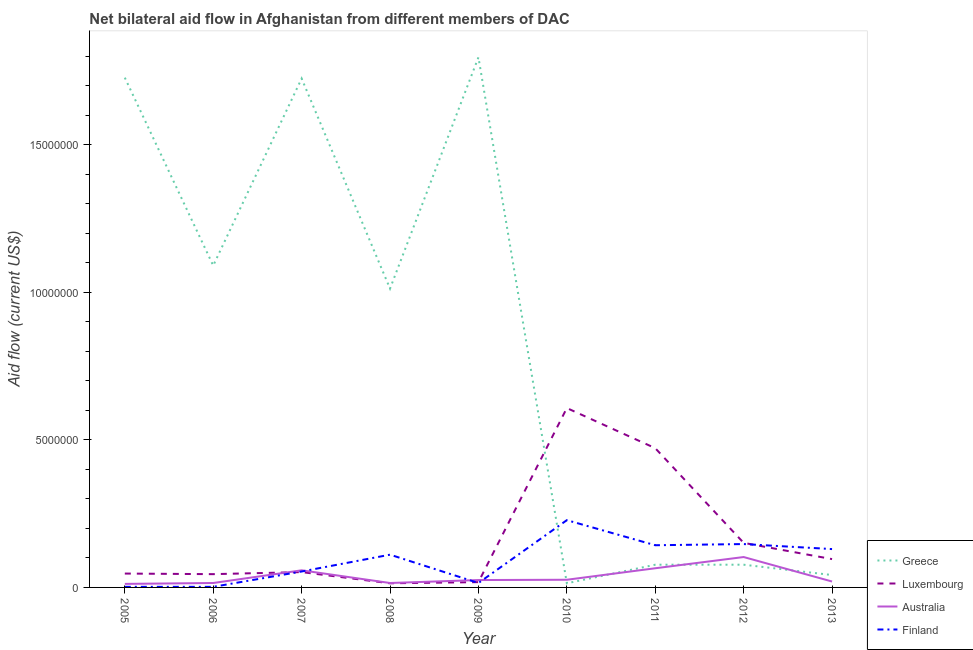How many different coloured lines are there?
Your answer should be very brief. 4. Does the line corresponding to amount of aid given by greece intersect with the line corresponding to amount of aid given by australia?
Give a very brief answer. Yes. What is the amount of aid given by finland in 2011?
Offer a terse response. 1.43e+06. Across all years, what is the maximum amount of aid given by greece?
Your response must be concise. 1.80e+07. Across all years, what is the minimum amount of aid given by finland?
Offer a terse response. 2.00e+04. In which year was the amount of aid given by luxembourg maximum?
Make the answer very short. 2010. In which year was the amount of aid given by australia minimum?
Offer a very short reply. 2005. What is the total amount of aid given by greece in the graph?
Your answer should be very brief. 7.56e+07. What is the difference between the amount of aid given by australia in 2008 and that in 2009?
Provide a succinct answer. -1.00e+05. What is the difference between the amount of aid given by greece in 2012 and the amount of aid given by australia in 2010?
Ensure brevity in your answer.  5.10e+05. What is the average amount of aid given by finland per year?
Keep it short and to the point. 9.24e+05. In the year 2007, what is the difference between the amount of aid given by greece and amount of aid given by australia?
Offer a very short reply. 1.67e+07. What is the ratio of the amount of aid given by finland in 2006 to that in 2007?
Provide a short and direct response. 0.04. Is the difference between the amount of aid given by australia in 2005 and 2007 greater than the difference between the amount of aid given by finland in 2005 and 2007?
Provide a succinct answer. Yes. What is the difference between the highest and the second highest amount of aid given by greece?
Your answer should be compact. 6.90e+05. What is the difference between the highest and the lowest amount of aid given by luxembourg?
Make the answer very short. 5.94e+06. In how many years, is the amount of aid given by australia greater than the average amount of aid given by australia taken over all years?
Provide a succinct answer. 3. Is the sum of the amount of aid given by australia in 2007 and 2010 greater than the maximum amount of aid given by finland across all years?
Offer a terse response. No. Is the amount of aid given by luxembourg strictly greater than the amount of aid given by australia over the years?
Ensure brevity in your answer.  No. How many lines are there?
Provide a short and direct response. 4. How many years are there in the graph?
Make the answer very short. 9. Are the values on the major ticks of Y-axis written in scientific E-notation?
Make the answer very short. No. Does the graph contain any zero values?
Offer a terse response. No. Does the graph contain grids?
Offer a very short reply. No. Where does the legend appear in the graph?
Give a very brief answer. Bottom right. What is the title of the graph?
Keep it short and to the point. Net bilateral aid flow in Afghanistan from different members of DAC. What is the Aid flow (current US$) in Greece in 2005?
Give a very brief answer. 1.73e+07. What is the Aid flow (current US$) in Australia in 2005?
Offer a terse response. 1.20e+05. What is the Aid flow (current US$) of Finland in 2005?
Your answer should be very brief. 2.00e+04. What is the Aid flow (current US$) of Greece in 2006?
Ensure brevity in your answer.  1.09e+07. What is the Aid flow (current US$) of Australia in 2006?
Give a very brief answer. 1.50e+05. What is the Aid flow (current US$) in Greece in 2007?
Keep it short and to the point. 1.72e+07. What is the Aid flow (current US$) of Luxembourg in 2007?
Give a very brief answer. 5.20e+05. What is the Aid flow (current US$) of Australia in 2007?
Make the answer very short. 5.80e+05. What is the Aid flow (current US$) of Finland in 2007?
Ensure brevity in your answer.  5.40e+05. What is the Aid flow (current US$) of Greece in 2008?
Provide a succinct answer. 1.01e+07. What is the Aid flow (current US$) in Finland in 2008?
Your answer should be very brief. 1.11e+06. What is the Aid flow (current US$) of Greece in 2009?
Provide a short and direct response. 1.80e+07. What is the Aid flow (current US$) in Australia in 2009?
Give a very brief answer. 2.50e+05. What is the Aid flow (current US$) of Greece in 2010?
Provide a short and direct response. 1.40e+05. What is the Aid flow (current US$) in Luxembourg in 2010?
Give a very brief answer. 6.08e+06. What is the Aid flow (current US$) in Finland in 2010?
Provide a succinct answer. 2.28e+06. What is the Aid flow (current US$) of Greece in 2011?
Make the answer very short. 7.70e+05. What is the Aid flow (current US$) in Luxembourg in 2011?
Ensure brevity in your answer.  4.72e+06. What is the Aid flow (current US$) in Australia in 2011?
Your answer should be compact. 6.50e+05. What is the Aid flow (current US$) in Finland in 2011?
Offer a terse response. 1.43e+06. What is the Aid flow (current US$) in Greece in 2012?
Your answer should be very brief. 7.70e+05. What is the Aid flow (current US$) in Luxembourg in 2012?
Give a very brief answer. 1.51e+06. What is the Aid flow (current US$) of Australia in 2012?
Your answer should be compact. 1.03e+06. What is the Aid flow (current US$) in Finland in 2012?
Keep it short and to the point. 1.47e+06. What is the Aid flow (current US$) in Greece in 2013?
Ensure brevity in your answer.  4.20e+05. What is the Aid flow (current US$) of Luxembourg in 2013?
Ensure brevity in your answer.  9.60e+05. What is the Aid flow (current US$) in Australia in 2013?
Ensure brevity in your answer.  2.00e+05. What is the Aid flow (current US$) in Finland in 2013?
Give a very brief answer. 1.30e+06. Across all years, what is the maximum Aid flow (current US$) of Greece?
Provide a succinct answer. 1.80e+07. Across all years, what is the maximum Aid flow (current US$) of Luxembourg?
Your answer should be compact. 6.08e+06. Across all years, what is the maximum Aid flow (current US$) of Australia?
Keep it short and to the point. 1.03e+06. Across all years, what is the maximum Aid flow (current US$) in Finland?
Your response must be concise. 2.28e+06. Across all years, what is the minimum Aid flow (current US$) of Greece?
Offer a terse response. 1.40e+05. Across all years, what is the minimum Aid flow (current US$) in Luxembourg?
Give a very brief answer. 1.40e+05. Across all years, what is the minimum Aid flow (current US$) in Australia?
Your response must be concise. 1.20e+05. Across all years, what is the minimum Aid flow (current US$) of Finland?
Ensure brevity in your answer.  2.00e+04. What is the total Aid flow (current US$) of Greece in the graph?
Your answer should be very brief. 7.56e+07. What is the total Aid flow (current US$) in Luxembourg in the graph?
Your answer should be very brief. 1.50e+07. What is the total Aid flow (current US$) in Australia in the graph?
Ensure brevity in your answer.  3.39e+06. What is the total Aid flow (current US$) of Finland in the graph?
Your response must be concise. 8.32e+06. What is the difference between the Aid flow (current US$) of Greece in 2005 and that in 2006?
Provide a short and direct response. 6.37e+06. What is the difference between the Aid flow (current US$) in Luxembourg in 2005 and that in 2006?
Give a very brief answer. 2.00e+04. What is the difference between the Aid flow (current US$) in Australia in 2005 and that in 2006?
Make the answer very short. -3.00e+04. What is the difference between the Aid flow (current US$) of Finland in 2005 and that in 2006?
Your response must be concise. 0. What is the difference between the Aid flow (current US$) of Greece in 2005 and that in 2007?
Offer a very short reply. 3.00e+04. What is the difference between the Aid flow (current US$) in Luxembourg in 2005 and that in 2007?
Offer a very short reply. -5.00e+04. What is the difference between the Aid flow (current US$) in Australia in 2005 and that in 2007?
Your answer should be compact. -4.60e+05. What is the difference between the Aid flow (current US$) of Finland in 2005 and that in 2007?
Offer a terse response. -5.20e+05. What is the difference between the Aid flow (current US$) in Greece in 2005 and that in 2008?
Ensure brevity in your answer.  7.15e+06. What is the difference between the Aid flow (current US$) of Finland in 2005 and that in 2008?
Your response must be concise. -1.09e+06. What is the difference between the Aid flow (current US$) of Greece in 2005 and that in 2009?
Provide a succinct answer. -6.90e+05. What is the difference between the Aid flow (current US$) of Luxembourg in 2005 and that in 2009?
Keep it short and to the point. 2.90e+05. What is the difference between the Aid flow (current US$) of Australia in 2005 and that in 2009?
Your answer should be compact. -1.30e+05. What is the difference between the Aid flow (current US$) in Finland in 2005 and that in 2009?
Ensure brevity in your answer.  -1.30e+05. What is the difference between the Aid flow (current US$) of Greece in 2005 and that in 2010?
Provide a succinct answer. 1.71e+07. What is the difference between the Aid flow (current US$) in Luxembourg in 2005 and that in 2010?
Ensure brevity in your answer.  -5.61e+06. What is the difference between the Aid flow (current US$) in Finland in 2005 and that in 2010?
Ensure brevity in your answer.  -2.26e+06. What is the difference between the Aid flow (current US$) of Greece in 2005 and that in 2011?
Give a very brief answer. 1.65e+07. What is the difference between the Aid flow (current US$) in Luxembourg in 2005 and that in 2011?
Your response must be concise. -4.25e+06. What is the difference between the Aid flow (current US$) of Australia in 2005 and that in 2011?
Offer a terse response. -5.30e+05. What is the difference between the Aid flow (current US$) of Finland in 2005 and that in 2011?
Give a very brief answer. -1.41e+06. What is the difference between the Aid flow (current US$) of Greece in 2005 and that in 2012?
Your response must be concise. 1.65e+07. What is the difference between the Aid flow (current US$) in Luxembourg in 2005 and that in 2012?
Give a very brief answer. -1.04e+06. What is the difference between the Aid flow (current US$) of Australia in 2005 and that in 2012?
Offer a terse response. -9.10e+05. What is the difference between the Aid flow (current US$) of Finland in 2005 and that in 2012?
Your answer should be compact. -1.45e+06. What is the difference between the Aid flow (current US$) of Greece in 2005 and that in 2013?
Your answer should be compact. 1.69e+07. What is the difference between the Aid flow (current US$) in Luxembourg in 2005 and that in 2013?
Keep it short and to the point. -4.90e+05. What is the difference between the Aid flow (current US$) in Finland in 2005 and that in 2013?
Offer a very short reply. -1.28e+06. What is the difference between the Aid flow (current US$) in Greece in 2006 and that in 2007?
Offer a terse response. -6.34e+06. What is the difference between the Aid flow (current US$) in Australia in 2006 and that in 2007?
Your answer should be compact. -4.30e+05. What is the difference between the Aid flow (current US$) of Finland in 2006 and that in 2007?
Provide a succinct answer. -5.20e+05. What is the difference between the Aid flow (current US$) in Greece in 2006 and that in 2008?
Provide a succinct answer. 7.80e+05. What is the difference between the Aid flow (current US$) in Australia in 2006 and that in 2008?
Provide a succinct answer. 0. What is the difference between the Aid flow (current US$) in Finland in 2006 and that in 2008?
Provide a succinct answer. -1.09e+06. What is the difference between the Aid flow (current US$) in Greece in 2006 and that in 2009?
Offer a very short reply. -7.06e+06. What is the difference between the Aid flow (current US$) in Luxembourg in 2006 and that in 2009?
Provide a succinct answer. 2.70e+05. What is the difference between the Aid flow (current US$) in Greece in 2006 and that in 2010?
Your answer should be compact. 1.08e+07. What is the difference between the Aid flow (current US$) of Luxembourg in 2006 and that in 2010?
Provide a succinct answer. -5.63e+06. What is the difference between the Aid flow (current US$) of Australia in 2006 and that in 2010?
Your response must be concise. -1.10e+05. What is the difference between the Aid flow (current US$) of Finland in 2006 and that in 2010?
Keep it short and to the point. -2.26e+06. What is the difference between the Aid flow (current US$) of Greece in 2006 and that in 2011?
Provide a short and direct response. 1.01e+07. What is the difference between the Aid flow (current US$) of Luxembourg in 2006 and that in 2011?
Your answer should be very brief. -4.27e+06. What is the difference between the Aid flow (current US$) in Australia in 2006 and that in 2011?
Your answer should be compact. -5.00e+05. What is the difference between the Aid flow (current US$) of Finland in 2006 and that in 2011?
Your response must be concise. -1.41e+06. What is the difference between the Aid flow (current US$) of Greece in 2006 and that in 2012?
Your answer should be very brief. 1.01e+07. What is the difference between the Aid flow (current US$) in Luxembourg in 2006 and that in 2012?
Your answer should be compact. -1.06e+06. What is the difference between the Aid flow (current US$) in Australia in 2006 and that in 2012?
Offer a very short reply. -8.80e+05. What is the difference between the Aid flow (current US$) in Finland in 2006 and that in 2012?
Your answer should be compact. -1.45e+06. What is the difference between the Aid flow (current US$) in Greece in 2006 and that in 2013?
Make the answer very short. 1.05e+07. What is the difference between the Aid flow (current US$) of Luxembourg in 2006 and that in 2013?
Provide a succinct answer. -5.10e+05. What is the difference between the Aid flow (current US$) of Finland in 2006 and that in 2013?
Provide a succinct answer. -1.28e+06. What is the difference between the Aid flow (current US$) in Greece in 2007 and that in 2008?
Your answer should be very brief. 7.12e+06. What is the difference between the Aid flow (current US$) of Luxembourg in 2007 and that in 2008?
Offer a very short reply. 3.80e+05. What is the difference between the Aid flow (current US$) in Australia in 2007 and that in 2008?
Your answer should be very brief. 4.30e+05. What is the difference between the Aid flow (current US$) in Finland in 2007 and that in 2008?
Your answer should be very brief. -5.70e+05. What is the difference between the Aid flow (current US$) in Greece in 2007 and that in 2009?
Keep it short and to the point. -7.20e+05. What is the difference between the Aid flow (current US$) of Luxembourg in 2007 and that in 2009?
Provide a short and direct response. 3.40e+05. What is the difference between the Aid flow (current US$) in Greece in 2007 and that in 2010?
Your response must be concise. 1.71e+07. What is the difference between the Aid flow (current US$) in Luxembourg in 2007 and that in 2010?
Offer a very short reply. -5.56e+06. What is the difference between the Aid flow (current US$) of Australia in 2007 and that in 2010?
Ensure brevity in your answer.  3.20e+05. What is the difference between the Aid flow (current US$) of Finland in 2007 and that in 2010?
Ensure brevity in your answer.  -1.74e+06. What is the difference between the Aid flow (current US$) in Greece in 2007 and that in 2011?
Offer a terse response. 1.65e+07. What is the difference between the Aid flow (current US$) of Luxembourg in 2007 and that in 2011?
Make the answer very short. -4.20e+06. What is the difference between the Aid flow (current US$) in Finland in 2007 and that in 2011?
Ensure brevity in your answer.  -8.90e+05. What is the difference between the Aid flow (current US$) in Greece in 2007 and that in 2012?
Offer a very short reply. 1.65e+07. What is the difference between the Aid flow (current US$) in Luxembourg in 2007 and that in 2012?
Keep it short and to the point. -9.90e+05. What is the difference between the Aid flow (current US$) of Australia in 2007 and that in 2012?
Keep it short and to the point. -4.50e+05. What is the difference between the Aid flow (current US$) of Finland in 2007 and that in 2012?
Offer a terse response. -9.30e+05. What is the difference between the Aid flow (current US$) of Greece in 2007 and that in 2013?
Offer a terse response. 1.68e+07. What is the difference between the Aid flow (current US$) of Luxembourg in 2007 and that in 2013?
Your response must be concise. -4.40e+05. What is the difference between the Aid flow (current US$) in Australia in 2007 and that in 2013?
Provide a succinct answer. 3.80e+05. What is the difference between the Aid flow (current US$) in Finland in 2007 and that in 2013?
Keep it short and to the point. -7.60e+05. What is the difference between the Aid flow (current US$) of Greece in 2008 and that in 2009?
Offer a terse response. -7.84e+06. What is the difference between the Aid flow (current US$) in Finland in 2008 and that in 2009?
Your response must be concise. 9.60e+05. What is the difference between the Aid flow (current US$) in Greece in 2008 and that in 2010?
Ensure brevity in your answer.  9.99e+06. What is the difference between the Aid flow (current US$) of Luxembourg in 2008 and that in 2010?
Ensure brevity in your answer.  -5.94e+06. What is the difference between the Aid flow (current US$) of Australia in 2008 and that in 2010?
Ensure brevity in your answer.  -1.10e+05. What is the difference between the Aid flow (current US$) of Finland in 2008 and that in 2010?
Ensure brevity in your answer.  -1.17e+06. What is the difference between the Aid flow (current US$) of Greece in 2008 and that in 2011?
Ensure brevity in your answer.  9.36e+06. What is the difference between the Aid flow (current US$) of Luxembourg in 2008 and that in 2011?
Provide a succinct answer. -4.58e+06. What is the difference between the Aid flow (current US$) in Australia in 2008 and that in 2011?
Provide a succinct answer. -5.00e+05. What is the difference between the Aid flow (current US$) of Finland in 2008 and that in 2011?
Provide a short and direct response. -3.20e+05. What is the difference between the Aid flow (current US$) in Greece in 2008 and that in 2012?
Offer a very short reply. 9.36e+06. What is the difference between the Aid flow (current US$) in Luxembourg in 2008 and that in 2012?
Provide a succinct answer. -1.37e+06. What is the difference between the Aid flow (current US$) of Australia in 2008 and that in 2012?
Offer a terse response. -8.80e+05. What is the difference between the Aid flow (current US$) of Finland in 2008 and that in 2012?
Provide a succinct answer. -3.60e+05. What is the difference between the Aid flow (current US$) in Greece in 2008 and that in 2013?
Provide a short and direct response. 9.71e+06. What is the difference between the Aid flow (current US$) of Luxembourg in 2008 and that in 2013?
Your answer should be very brief. -8.20e+05. What is the difference between the Aid flow (current US$) in Finland in 2008 and that in 2013?
Keep it short and to the point. -1.90e+05. What is the difference between the Aid flow (current US$) in Greece in 2009 and that in 2010?
Your response must be concise. 1.78e+07. What is the difference between the Aid flow (current US$) in Luxembourg in 2009 and that in 2010?
Provide a short and direct response. -5.90e+06. What is the difference between the Aid flow (current US$) of Australia in 2009 and that in 2010?
Your answer should be very brief. -10000. What is the difference between the Aid flow (current US$) in Finland in 2009 and that in 2010?
Ensure brevity in your answer.  -2.13e+06. What is the difference between the Aid flow (current US$) in Greece in 2009 and that in 2011?
Ensure brevity in your answer.  1.72e+07. What is the difference between the Aid flow (current US$) in Luxembourg in 2009 and that in 2011?
Your answer should be compact. -4.54e+06. What is the difference between the Aid flow (current US$) in Australia in 2009 and that in 2011?
Give a very brief answer. -4.00e+05. What is the difference between the Aid flow (current US$) in Finland in 2009 and that in 2011?
Your response must be concise. -1.28e+06. What is the difference between the Aid flow (current US$) in Greece in 2009 and that in 2012?
Provide a short and direct response. 1.72e+07. What is the difference between the Aid flow (current US$) in Luxembourg in 2009 and that in 2012?
Offer a terse response. -1.33e+06. What is the difference between the Aid flow (current US$) of Australia in 2009 and that in 2012?
Provide a succinct answer. -7.80e+05. What is the difference between the Aid flow (current US$) of Finland in 2009 and that in 2012?
Your answer should be very brief. -1.32e+06. What is the difference between the Aid flow (current US$) of Greece in 2009 and that in 2013?
Provide a succinct answer. 1.76e+07. What is the difference between the Aid flow (current US$) of Luxembourg in 2009 and that in 2013?
Provide a short and direct response. -7.80e+05. What is the difference between the Aid flow (current US$) of Australia in 2009 and that in 2013?
Your answer should be very brief. 5.00e+04. What is the difference between the Aid flow (current US$) in Finland in 2009 and that in 2013?
Offer a very short reply. -1.15e+06. What is the difference between the Aid flow (current US$) in Greece in 2010 and that in 2011?
Provide a succinct answer. -6.30e+05. What is the difference between the Aid flow (current US$) in Luxembourg in 2010 and that in 2011?
Provide a succinct answer. 1.36e+06. What is the difference between the Aid flow (current US$) in Australia in 2010 and that in 2011?
Provide a succinct answer. -3.90e+05. What is the difference between the Aid flow (current US$) of Finland in 2010 and that in 2011?
Ensure brevity in your answer.  8.50e+05. What is the difference between the Aid flow (current US$) of Greece in 2010 and that in 2012?
Make the answer very short. -6.30e+05. What is the difference between the Aid flow (current US$) in Luxembourg in 2010 and that in 2012?
Provide a succinct answer. 4.57e+06. What is the difference between the Aid flow (current US$) of Australia in 2010 and that in 2012?
Provide a short and direct response. -7.70e+05. What is the difference between the Aid flow (current US$) in Finland in 2010 and that in 2012?
Make the answer very short. 8.10e+05. What is the difference between the Aid flow (current US$) of Greece in 2010 and that in 2013?
Provide a succinct answer. -2.80e+05. What is the difference between the Aid flow (current US$) in Luxembourg in 2010 and that in 2013?
Your answer should be very brief. 5.12e+06. What is the difference between the Aid flow (current US$) of Australia in 2010 and that in 2013?
Your answer should be compact. 6.00e+04. What is the difference between the Aid flow (current US$) in Finland in 2010 and that in 2013?
Provide a succinct answer. 9.80e+05. What is the difference between the Aid flow (current US$) of Luxembourg in 2011 and that in 2012?
Give a very brief answer. 3.21e+06. What is the difference between the Aid flow (current US$) in Australia in 2011 and that in 2012?
Your answer should be compact. -3.80e+05. What is the difference between the Aid flow (current US$) in Greece in 2011 and that in 2013?
Provide a succinct answer. 3.50e+05. What is the difference between the Aid flow (current US$) in Luxembourg in 2011 and that in 2013?
Offer a very short reply. 3.76e+06. What is the difference between the Aid flow (current US$) of Greece in 2012 and that in 2013?
Provide a succinct answer. 3.50e+05. What is the difference between the Aid flow (current US$) of Australia in 2012 and that in 2013?
Offer a very short reply. 8.30e+05. What is the difference between the Aid flow (current US$) of Greece in 2005 and the Aid flow (current US$) of Luxembourg in 2006?
Your answer should be compact. 1.68e+07. What is the difference between the Aid flow (current US$) in Greece in 2005 and the Aid flow (current US$) in Australia in 2006?
Offer a very short reply. 1.71e+07. What is the difference between the Aid flow (current US$) of Greece in 2005 and the Aid flow (current US$) of Finland in 2006?
Your response must be concise. 1.73e+07. What is the difference between the Aid flow (current US$) in Australia in 2005 and the Aid flow (current US$) in Finland in 2006?
Make the answer very short. 1.00e+05. What is the difference between the Aid flow (current US$) in Greece in 2005 and the Aid flow (current US$) in Luxembourg in 2007?
Offer a very short reply. 1.68e+07. What is the difference between the Aid flow (current US$) of Greece in 2005 and the Aid flow (current US$) of Australia in 2007?
Make the answer very short. 1.67e+07. What is the difference between the Aid flow (current US$) in Greece in 2005 and the Aid flow (current US$) in Finland in 2007?
Offer a very short reply. 1.67e+07. What is the difference between the Aid flow (current US$) in Luxembourg in 2005 and the Aid flow (current US$) in Australia in 2007?
Provide a succinct answer. -1.10e+05. What is the difference between the Aid flow (current US$) in Luxembourg in 2005 and the Aid flow (current US$) in Finland in 2007?
Ensure brevity in your answer.  -7.00e+04. What is the difference between the Aid flow (current US$) of Australia in 2005 and the Aid flow (current US$) of Finland in 2007?
Your answer should be very brief. -4.20e+05. What is the difference between the Aid flow (current US$) in Greece in 2005 and the Aid flow (current US$) in Luxembourg in 2008?
Provide a succinct answer. 1.71e+07. What is the difference between the Aid flow (current US$) in Greece in 2005 and the Aid flow (current US$) in Australia in 2008?
Your answer should be compact. 1.71e+07. What is the difference between the Aid flow (current US$) in Greece in 2005 and the Aid flow (current US$) in Finland in 2008?
Your response must be concise. 1.62e+07. What is the difference between the Aid flow (current US$) of Luxembourg in 2005 and the Aid flow (current US$) of Australia in 2008?
Your response must be concise. 3.20e+05. What is the difference between the Aid flow (current US$) in Luxembourg in 2005 and the Aid flow (current US$) in Finland in 2008?
Make the answer very short. -6.40e+05. What is the difference between the Aid flow (current US$) of Australia in 2005 and the Aid flow (current US$) of Finland in 2008?
Your answer should be very brief. -9.90e+05. What is the difference between the Aid flow (current US$) in Greece in 2005 and the Aid flow (current US$) in Luxembourg in 2009?
Your response must be concise. 1.71e+07. What is the difference between the Aid flow (current US$) in Greece in 2005 and the Aid flow (current US$) in Australia in 2009?
Ensure brevity in your answer.  1.70e+07. What is the difference between the Aid flow (current US$) in Greece in 2005 and the Aid flow (current US$) in Finland in 2009?
Your answer should be compact. 1.71e+07. What is the difference between the Aid flow (current US$) of Luxembourg in 2005 and the Aid flow (current US$) of Finland in 2009?
Ensure brevity in your answer.  3.20e+05. What is the difference between the Aid flow (current US$) in Australia in 2005 and the Aid flow (current US$) in Finland in 2009?
Provide a succinct answer. -3.00e+04. What is the difference between the Aid flow (current US$) in Greece in 2005 and the Aid flow (current US$) in Luxembourg in 2010?
Offer a terse response. 1.12e+07. What is the difference between the Aid flow (current US$) of Greece in 2005 and the Aid flow (current US$) of Australia in 2010?
Make the answer very short. 1.70e+07. What is the difference between the Aid flow (current US$) in Greece in 2005 and the Aid flow (current US$) in Finland in 2010?
Ensure brevity in your answer.  1.50e+07. What is the difference between the Aid flow (current US$) in Luxembourg in 2005 and the Aid flow (current US$) in Australia in 2010?
Ensure brevity in your answer.  2.10e+05. What is the difference between the Aid flow (current US$) of Luxembourg in 2005 and the Aid flow (current US$) of Finland in 2010?
Ensure brevity in your answer.  -1.81e+06. What is the difference between the Aid flow (current US$) of Australia in 2005 and the Aid flow (current US$) of Finland in 2010?
Provide a succinct answer. -2.16e+06. What is the difference between the Aid flow (current US$) in Greece in 2005 and the Aid flow (current US$) in Luxembourg in 2011?
Offer a terse response. 1.26e+07. What is the difference between the Aid flow (current US$) in Greece in 2005 and the Aid flow (current US$) in Australia in 2011?
Provide a succinct answer. 1.66e+07. What is the difference between the Aid flow (current US$) in Greece in 2005 and the Aid flow (current US$) in Finland in 2011?
Keep it short and to the point. 1.58e+07. What is the difference between the Aid flow (current US$) of Luxembourg in 2005 and the Aid flow (current US$) of Australia in 2011?
Your answer should be compact. -1.80e+05. What is the difference between the Aid flow (current US$) of Luxembourg in 2005 and the Aid flow (current US$) of Finland in 2011?
Give a very brief answer. -9.60e+05. What is the difference between the Aid flow (current US$) in Australia in 2005 and the Aid flow (current US$) in Finland in 2011?
Provide a succinct answer. -1.31e+06. What is the difference between the Aid flow (current US$) in Greece in 2005 and the Aid flow (current US$) in Luxembourg in 2012?
Give a very brief answer. 1.58e+07. What is the difference between the Aid flow (current US$) in Greece in 2005 and the Aid flow (current US$) in Australia in 2012?
Your answer should be compact. 1.62e+07. What is the difference between the Aid flow (current US$) of Greece in 2005 and the Aid flow (current US$) of Finland in 2012?
Offer a very short reply. 1.58e+07. What is the difference between the Aid flow (current US$) of Luxembourg in 2005 and the Aid flow (current US$) of Australia in 2012?
Your answer should be very brief. -5.60e+05. What is the difference between the Aid flow (current US$) of Luxembourg in 2005 and the Aid flow (current US$) of Finland in 2012?
Your answer should be very brief. -1.00e+06. What is the difference between the Aid flow (current US$) in Australia in 2005 and the Aid flow (current US$) in Finland in 2012?
Your answer should be very brief. -1.35e+06. What is the difference between the Aid flow (current US$) in Greece in 2005 and the Aid flow (current US$) in Luxembourg in 2013?
Provide a succinct answer. 1.63e+07. What is the difference between the Aid flow (current US$) in Greece in 2005 and the Aid flow (current US$) in Australia in 2013?
Offer a terse response. 1.71e+07. What is the difference between the Aid flow (current US$) of Greece in 2005 and the Aid flow (current US$) of Finland in 2013?
Offer a very short reply. 1.60e+07. What is the difference between the Aid flow (current US$) in Luxembourg in 2005 and the Aid flow (current US$) in Australia in 2013?
Give a very brief answer. 2.70e+05. What is the difference between the Aid flow (current US$) of Luxembourg in 2005 and the Aid flow (current US$) of Finland in 2013?
Give a very brief answer. -8.30e+05. What is the difference between the Aid flow (current US$) in Australia in 2005 and the Aid flow (current US$) in Finland in 2013?
Keep it short and to the point. -1.18e+06. What is the difference between the Aid flow (current US$) in Greece in 2006 and the Aid flow (current US$) in Luxembourg in 2007?
Your answer should be compact. 1.04e+07. What is the difference between the Aid flow (current US$) of Greece in 2006 and the Aid flow (current US$) of Australia in 2007?
Your answer should be compact. 1.03e+07. What is the difference between the Aid flow (current US$) in Greece in 2006 and the Aid flow (current US$) in Finland in 2007?
Keep it short and to the point. 1.04e+07. What is the difference between the Aid flow (current US$) of Luxembourg in 2006 and the Aid flow (current US$) of Australia in 2007?
Offer a very short reply. -1.30e+05. What is the difference between the Aid flow (current US$) of Australia in 2006 and the Aid flow (current US$) of Finland in 2007?
Provide a short and direct response. -3.90e+05. What is the difference between the Aid flow (current US$) in Greece in 2006 and the Aid flow (current US$) in Luxembourg in 2008?
Your answer should be very brief. 1.08e+07. What is the difference between the Aid flow (current US$) of Greece in 2006 and the Aid flow (current US$) of Australia in 2008?
Keep it short and to the point. 1.08e+07. What is the difference between the Aid flow (current US$) in Greece in 2006 and the Aid flow (current US$) in Finland in 2008?
Offer a very short reply. 9.80e+06. What is the difference between the Aid flow (current US$) in Luxembourg in 2006 and the Aid flow (current US$) in Finland in 2008?
Keep it short and to the point. -6.60e+05. What is the difference between the Aid flow (current US$) in Australia in 2006 and the Aid flow (current US$) in Finland in 2008?
Offer a terse response. -9.60e+05. What is the difference between the Aid flow (current US$) in Greece in 2006 and the Aid flow (current US$) in Luxembourg in 2009?
Ensure brevity in your answer.  1.07e+07. What is the difference between the Aid flow (current US$) in Greece in 2006 and the Aid flow (current US$) in Australia in 2009?
Your answer should be very brief. 1.07e+07. What is the difference between the Aid flow (current US$) of Greece in 2006 and the Aid flow (current US$) of Finland in 2009?
Your response must be concise. 1.08e+07. What is the difference between the Aid flow (current US$) in Luxembourg in 2006 and the Aid flow (current US$) in Finland in 2009?
Give a very brief answer. 3.00e+05. What is the difference between the Aid flow (current US$) in Australia in 2006 and the Aid flow (current US$) in Finland in 2009?
Your answer should be very brief. 0. What is the difference between the Aid flow (current US$) in Greece in 2006 and the Aid flow (current US$) in Luxembourg in 2010?
Provide a short and direct response. 4.83e+06. What is the difference between the Aid flow (current US$) in Greece in 2006 and the Aid flow (current US$) in Australia in 2010?
Provide a succinct answer. 1.06e+07. What is the difference between the Aid flow (current US$) of Greece in 2006 and the Aid flow (current US$) of Finland in 2010?
Make the answer very short. 8.63e+06. What is the difference between the Aid flow (current US$) in Luxembourg in 2006 and the Aid flow (current US$) in Australia in 2010?
Give a very brief answer. 1.90e+05. What is the difference between the Aid flow (current US$) of Luxembourg in 2006 and the Aid flow (current US$) of Finland in 2010?
Offer a terse response. -1.83e+06. What is the difference between the Aid flow (current US$) in Australia in 2006 and the Aid flow (current US$) in Finland in 2010?
Your answer should be very brief. -2.13e+06. What is the difference between the Aid flow (current US$) in Greece in 2006 and the Aid flow (current US$) in Luxembourg in 2011?
Provide a succinct answer. 6.19e+06. What is the difference between the Aid flow (current US$) of Greece in 2006 and the Aid flow (current US$) of Australia in 2011?
Provide a succinct answer. 1.03e+07. What is the difference between the Aid flow (current US$) of Greece in 2006 and the Aid flow (current US$) of Finland in 2011?
Ensure brevity in your answer.  9.48e+06. What is the difference between the Aid flow (current US$) in Luxembourg in 2006 and the Aid flow (current US$) in Australia in 2011?
Keep it short and to the point. -2.00e+05. What is the difference between the Aid flow (current US$) in Luxembourg in 2006 and the Aid flow (current US$) in Finland in 2011?
Give a very brief answer. -9.80e+05. What is the difference between the Aid flow (current US$) of Australia in 2006 and the Aid flow (current US$) of Finland in 2011?
Provide a short and direct response. -1.28e+06. What is the difference between the Aid flow (current US$) of Greece in 2006 and the Aid flow (current US$) of Luxembourg in 2012?
Make the answer very short. 9.40e+06. What is the difference between the Aid flow (current US$) of Greece in 2006 and the Aid flow (current US$) of Australia in 2012?
Your answer should be compact. 9.88e+06. What is the difference between the Aid flow (current US$) in Greece in 2006 and the Aid flow (current US$) in Finland in 2012?
Your answer should be compact. 9.44e+06. What is the difference between the Aid flow (current US$) of Luxembourg in 2006 and the Aid flow (current US$) of Australia in 2012?
Ensure brevity in your answer.  -5.80e+05. What is the difference between the Aid flow (current US$) in Luxembourg in 2006 and the Aid flow (current US$) in Finland in 2012?
Keep it short and to the point. -1.02e+06. What is the difference between the Aid flow (current US$) in Australia in 2006 and the Aid flow (current US$) in Finland in 2012?
Make the answer very short. -1.32e+06. What is the difference between the Aid flow (current US$) of Greece in 2006 and the Aid flow (current US$) of Luxembourg in 2013?
Make the answer very short. 9.95e+06. What is the difference between the Aid flow (current US$) in Greece in 2006 and the Aid flow (current US$) in Australia in 2013?
Your response must be concise. 1.07e+07. What is the difference between the Aid flow (current US$) in Greece in 2006 and the Aid flow (current US$) in Finland in 2013?
Your answer should be very brief. 9.61e+06. What is the difference between the Aid flow (current US$) in Luxembourg in 2006 and the Aid flow (current US$) in Finland in 2013?
Provide a short and direct response. -8.50e+05. What is the difference between the Aid flow (current US$) of Australia in 2006 and the Aid flow (current US$) of Finland in 2013?
Offer a terse response. -1.15e+06. What is the difference between the Aid flow (current US$) in Greece in 2007 and the Aid flow (current US$) in Luxembourg in 2008?
Keep it short and to the point. 1.71e+07. What is the difference between the Aid flow (current US$) of Greece in 2007 and the Aid flow (current US$) of Australia in 2008?
Your answer should be very brief. 1.71e+07. What is the difference between the Aid flow (current US$) in Greece in 2007 and the Aid flow (current US$) in Finland in 2008?
Keep it short and to the point. 1.61e+07. What is the difference between the Aid flow (current US$) in Luxembourg in 2007 and the Aid flow (current US$) in Australia in 2008?
Offer a terse response. 3.70e+05. What is the difference between the Aid flow (current US$) of Luxembourg in 2007 and the Aid flow (current US$) of Finland in 2008?
Make the answer very short. -5.90e+05. What is the difference between the Aid flow (current US$) in Australia in 2007 and the Aid flow (current US$) in Finland in 2008?
Your answer should be very brief. -5.30e+05. What is the difference between the Aid flow (current US$) of Greece in 2007 and the Aid flow (current US$) of Luxembourg in 2009?
Provide a succinct answer. 1.71e+07. What is the difference between the Aid flow (current US$) in Greece in 2007 and the Aid flow (current US$) in Australia in 2009?
Your answer should be very brief. 1.70e+07. What is the difference between the Aid flow (current US$) of Greece in 2007 and the Aid flow (current US$) of Finland in 2009?
Ensure brevity in your answer.  1.71e+07. What is the difference between the Aid flow (current US$) in Greece in 2007 and the Aid flow (current US$) in Luxembourg in 2010?
Your answer should be very brief. 1.12e+07. What is the difference between the Aid flow (current US$) in Greece in 2007 and the Aid flow (current US$) in Australia in 2010?
Give a very brief answer. 1.70e+07. What is the difference between the Aid flow (current US$) of Greece in 2007 and the Aid flow (current US$) of Finland in 2010?
Your response must be concise. 1.50e+07. What is the difference between the Aid flow (current US$) in Luxembourg in 2007 and the Aid flow (current US$) in Finland in 2010?
Provide a short and direct response. -1.76e+06. What is the difference between the Aid flow (current US$) in Australia in 2007 and the Aid flow (current US$) in Finland in 2010?
Ensure brevity in your answer.  -1.70e+06. What is the difference between the Aid flow (current US$) in Greece in 2007 and the Aid flow (current US$) in Luxembourg in 2011?
Keep it short and to the point. 1.25e+07. What is the difference between the Aid flow (current US$) of Greece in 2007 and the Aid flow (current US$) of Australia in 2011?
Ensure brevity in your answer.  1.66e+07. What is the difference between the Aid flow (current US$) in Greece in 2007 and the Aid flow (current US$) in Finland in 2011?
Provide a succinct answer. 1.58e+07. What is the difference between the Aid flow (current US$) in Luxembourg in 2007 and the Aid flow (current US$) in Australia in 2011?
Keep it short and to the point. -1.30e+05. What is the difference between the Aid flow (current US$) of Luxembourg in 2007 and the Aid flow (current US$) of Finland in 2011?
Ensure brevity in your answer.  -9.10e+05. What is the difference between the Aid flow (current US$) of Australia in 2007 and the Aid flow (current US$) of Finland in 2011?
Make the answer very short. -8.50e+05. What is the difference between the Aid flow (current US$) in Greece in 2007 and the Aid flow (current US$) in Luxembourg in 2012?
Provide a succinct answer. 1.57e+07. What is the difference between the Aid flow (current US$) of Greece in 2007 and the Aid flow (current US$) of Australia in 2012?
Give a very brief answer. 1.62e+07. What is the difference between the Aid flow (current US$) of Greece in 2007 and the Aid flow (current US$) of Finland in 2012?
Provide a short and direct response. 1.58e+07. What is the difference between the Aid flow (current US$) in Luxembourg in 2007 and the Aid flow (current US$) in Australia in 2012?
Ensure brevity in your answer.  -5.10e+05. What is the difference between the Aid flow (current US$) of Luxembourg in 2007 and the Aid flow (current US$) of Finland in 2012?
Your answer should be very brief. -9.50e+05. What is the difference between the Aid flow (current US$) in Australia in 2007 and the Aid flow (current US$) in Finland in 2012?
Offer a terse response. -8.90e+05. What is the difference between the Aid flow (current US$) of Greece in 2007 and the Aid flow (current US$) of Luxembourg in 2013?
Your answer should be very brief. 1.63e+07. What is the difference between the Aid flow (current US$) in Greece in 2007 and the Aid flow (current US$) in Australia in 2013?
Offer a terse response. 1.70e+07. What is the difference between the Aid flow (current US$) of Greece in 2007 and the Aid flow (current US$) of Finland in 2013?
Make the answer very short. 1.60e+07. What is the difference between the Aid flow (current US$) in Luxembourg in 2007 and the Aid flow (current US$) in Finland in 2013?
Offer a very short reply. -7.80e+05. What is the difference between the Aid flow (current US$) of Australia in 2007 and the Aid flow (current US$) of Finland in 2013?
Keep it short and to the point. -7.20e+05. What is the difference between the Aid flow (current US$) of Greece in 2008 and the Aid flow (current US$) of Luxembourg in 2009?
Make the answer very short. 9.95e+06. What is the difference between the Aid flow (current US$) of Greece in 2008 and the Aid flow (current US$) of Australia in 2009?
Make the answer very short. 9.88e+06. What is the difference between the Aid flow (current US$) in Greece in 2008 and the Aid flow (current US$) in Finland in 2009?
Ensure brevity in your answer.  9.98e+06. What is the difference between the Aid flow (current US$) of Luxembourg in 2008 and the Aid flow (current US$) of Australia in 2009?
Your answer should be compact. -1.10e+05. What is the difference between the Aid flow (current US$) in Luxembourg in 2008 and the Aid flow (current US$) in Finland in 2009?
Make the answer very short. -10000. What is the difference between the Aid flow (current US$) of Australia in 2008 and the Aid flow (current US$) of Finland in 2009?
Make the answer very short. 0. What is the difference between the Aid flow (current US$) of Greece in 2008 and the Aid flow (current US$) of Luxembourg in 2010?
Keep it short and to the point. 4.05e+06. What is the difference between the Aid flow (current US$) in Greece in 2008 and the Aid flow (current US$) in Australia in 2010?
Your answer should be compact. 9.87e+06. What is the difference between the Aid flow (current US$) in Greece in 2008 and the Aid flow (current US$) in Finland in 2010?
Ensure brevity in your answer.  7.85e+06. What is the difference between the Aid flow (current US$) in Luxembourg in 2008 and the Aid flow (current US$) in Finland in 2010?
Offer a very short reply. -2.14e+06. What is the difference between the Aid flow (current US$) in Australia in 2008 and the Aid flow (current US$) in Finland in 2010?
Offer a terse response. -2.13e+06. What is the difference between the Aid flow (current US$) in Greece in 2008 and the Aid flow (current US$) in Luxembourg in 2011?
Provide a short and direct response. 5.41e+06. What is the difference between the Aid flow (current US$) in Greece in 2008 and the Aid flow (current US$) in Australia in 2011?
Give a very brief answer. 9.48e+06. What is the difference between the Aid flow (current US$) of Greece in 2008 and the Aid flow (current US$) of Finland in 2011?
Make the answer very short. 8.70e+06. What is the difference between the Aid flow (current US$) of Luxembourg in 2008 and the Aid flow (current US$) of Australia in 2011?
Offer a terse response. -5.10e+05. What is the difference between the Aid flow (current US$) in Luxembourg in 2008 and the Aid flow (current US$) in Finland in 2011?
Ensure brevity in your answer.  -1.29e+06. What is the difference between the Aid flow (current US$) in Australia in 2008 and the Aid flow (current US$) in Finland in 2011?
Your answer should be compact. -1.28e+06. What is the difference between the Aid flow (current US$) in Greece in 2008 and the Aid flow (current US$) in Luxembourg in 2012?
Make the answer very short. 8.62e+06. What is the difference between the Aid flow (current US$) in Greece in 2008 and the Aid flow (current US$) in Australia in 2012?
Provide a short and direct response. 9.10e+06. What is the difference between the Aid flow (current US$) in Greece in 2008 and the Aid flow (current US$) in Finland in 2012?
Make the answer very short. 8.66e+06. What is the difference between the Aid flow (current US$) of Luxembourg in 2008 and the Aid flow (current US$) of Australia in 2012?
Offer a terse response. -8.90e+05. What is the difference between the Aid flow (current US$) of Luxembourg in 2008 and the Aid flow (current US$) of Finland in 2012?
Offer a terse response. -1.33e+06. What is the difference between the Aid flow (current US$) in Australia in 2008 and the Aid flow (current US$) in Finland in 2012?
Make the answer very short. -1.32e+06. What is the difference between the Aid flow (current US$) in Greece in 2008 and the Aid flow (current US$) in Luxembourg in 2013?
Keep it short and to the point. 9.17e+06. What is the difference between the Aid flow (current US$) in Greece in 2008 and the Aid flow (current US$) in Australia in 2013?
Provide a short and direct response. 9.93e+06. What is the difference between the Aid flow (current US$) of Greece in 2008 and the Aid flow (current US$) of Finland in 2013?
Your answer should be very brief. 8.83e+06. What is the difference between the Aid flow (current US$) of Luxembourg in 2008 and the Aid flow (current US$) of Finland in 2013?
Offer a terse response. -1.16e+06. What is the difference between the Aid flow (current US$) in Australia in 2008 and the Aid flow (current US$) in Finland in 2013?
Ensure brevity in your answer.  -1.15e+06. What is the difference between the Aid flow (current US$) of Greece in 2009 and the Aid flow (current US$) of Luxembourg in 2010?
Offer a terse response. 1.19e+07. What is the difference between the Aid flow (current US$) in Greece in 2009 and the Aid flow (current US$) in Australia in 2010?
Your answer should be very brief. 1.77e+07. What is the difference between the Aid flow (current US$) in Greece in 2009 and the Aid flow (current US$) in Finland in 2010?
Keep it short and to the point. 1.57e+07. What is the difference between the Aid flow (current US$) of Luxembourg in 2009 and the Aid flow (current US$) of Australia in 2010?
Your response must be concise. -8.00e+04. What is the difference between the Aid flow (current US$) of Luxembourg in 2009 and the Aid flow (current US$) of Finland in 2010?
Offer a terse response. -2.10e+06. What is the difference between the Aid flow (current US$) of Australia in 2009 and the Aid flow (current US$) of Finland in 2010?
Your answer should be very brief. -2.03e+06. What is the difference between the Aid flow (current US$) of Greece in 2009 and the Aid flow (current US$) of Luxembourg in 2011?
Your response must be concise. 1.32e+07. What is the difference between the Aid flow (current US$) of Greece in 2009 and the Aid flow (current US$) of Australia in 2011?
Offer a very short reply. 1.73e+07. What is the difference between the Aid flow (current US$) in Greece in 2009 and the Aid flow (current US$) in Finland in 2011?
Provide a short and direct response. 1.65e+07. What is the difference between the Aid flow (current US$) of Luxembourg in 2009 and the Aid flow (current US$) of Australia in 2011?
Provide a short and direct response. -4.70e+05. What is the difference between the Aid flow (current US$) of Luxembourg in 2009 and the Aid flow (current US$) of Finland in 2011?
Offer a very short reply. -1.25e+06. What is the difference between the Aid flow (current US$) of Australia in 2009 and the Aid flow (current US$) of Finland in 2011?
Provide a succinct answer. -1.18e+06. What is the difference between the Aid flow (current US$) of Greece in 2009 and the Aid flow (current US$) of Luxembourg in 2012?
Your answer should be compact. 1.65e+07. What is the difference between the Aid flow (current US$) in Greece in 2009 and the Aid flow (current US$) in Australia in 2012?
Your response must be concise. 1.69e+07. What is the difference between the Aid flow (current US$) in Greece in 2009 and the Aid flow (current US$) in Finland in 2012?
Ensure brevity in your answer.  1.65e+07. What is the difference between the Aid flow (current US$) in Luxembourg in 2009 and the Aid flow (current US$) in Australia in 2012?
Offer a very short reply. -8.50e+05. What is the difference between the Aid flow (current US$) of Luxembourg in 2009 and the Aid flow (current US$) of Finland in 2012?
Your response must be concise. -1.29e+06. What is the difference between the Aid flow (current US$) in Australia in 2009 and the Aid flow (current US$) in Finland in 2012?
Provide a succinct answer. -1.22e+06. What is the difference between the Aid flow (current US$) of Greece in 2009 and the Aid flow (current US$) of Luxembourg in 2013?
Provide a short and direct response. 1.70e+07. What is the difference between the Aid flow (current US$) in Greece in 2009 and the Aid flow (current US$) in Australia in 2013?
Your answer should be compact. 1.78e+07. What is the difference between the Aid flow (current US$) of Greece in 2009 and the Aid flow (current US$) of Finland in 2013?
Your answer should be very brief. 1.67e+07. What is the difference between the Aid flow (current US$) of Luxembourg in 2009 and the Aid flow (current US$) of Finland in 2013?
Your response must be concise. -1.12e+06. What is the difference between the Aid flow (current US$) of Australia in 2009 and the Aid flow (current US$) of Finland in 2013?
Offer a very short reply. -1.05e+06. What is the difference between the Aid flow (current US$) in Greece in 2010 and the Aid flow (current US$) in Luxembourg in 2011?
Make the answer very short. -4.58e+06. What is the difference between the Aid flow (current US$) in Greece in 2010 and the Aid flow (current US$) in Australia in 2011?
Offer a very short reply. -5.10e+05. What is the difference between the Aid flow (current US$) of Greece in 2010 and the Aid flow (current US$) of Finland in 2011?
Your answer should be compact. -1.29e+06. What is the difference between the Aid flow (current US$) of Luxembourg in 2010 and the Aid flow (current US$) of Australia in 2011?
Ensure brevity in your answer.  5.43e+06. What is the difference between the Aid flow (current US$) in Luxembourg in 2010 and the Aid flow (current US$) in Finland in 2011?
Offer a very short reply. 4.65e+06. What is the difference between the Aid flow (current US$) in Australia in 2010 and the Aid flow (current US$) in Finland in 2011?
Offer a very short reply. -1.17e+06. What is the difference between the Aid flow (current US$) in Greece in 2010 and the Aid flow (current US$) in Luxembourg in 2012?
Your response must be concise. -1.37e+06. What is the difference between the Aid flow (current US$) of Greece in 2010 and the Aid flow (current US$) of Australia in 2012?
Keep it short and to the point. -8.90e+05. What is the difference between the Aid flow (current US$) in Greece in 2010 and the Aid flow (current US$) in Finland in 2012?
Provide a succinct answer. -1.33e+06. What is the difference between the Aid flow (current US$) in Luxembourg in 2010 and the Aid flow (current US$) in Australia in 2012?
Offer a very short reply. 5.05e+06. What is the difference between the Aid flow (current US$) of Luxembourg in 2010 and the Aid flow (current US$) of Finland in 2012?
Ensure brevity in your answer.  4.61e+06. What is the difference between the Aid flow (current US$) of Australia in 2010 and the Aid flow (current US$) of Finland in 2012?
Give a very brief answer. -1.21e+06. What is the difference between the Aid flow (current US$) of Greece in 2010 and the Aid flow (current US$) of Luxembourg in 2013?
Your response must be concise. -8.20e+05. What is the difference between the Aid flow (current US$) of Greece in 2010 and the Aid flow (current US$) of Finland in 2013?
Offer a very short reply. -1.16e+06. What is the difference between the Aid flow (current US$) in Luxembourg in 2010 and the Aid flow (current US$) in Australia in 2013?
Provide a short and direct response. 5.88e+06. What is the difference between the Aid flow (current US$) in Luxembourg in 2010 and the Aid flow (current US$) in Finland in 2013?
Your answer should be very brief. 4.78e+06. What is the difference between the Aid flow (current US$) of Australia in 2010 and the Aid flow (current US$) of Finland in 2013?
Your answer should be very brief. -1.04e+06. What is the difference between the Aid flow (current US$) of Greece in 2011 and the Aid flow (current US$) of Luxembourg in 2012?
Make the answer very short. -7.40e+05. What is the difference between the Aid flow (current US$) of Greece in 2011 and the Aid flow (current US$) of Australia in 2012?
Ensure brevity in your answer.  -2.60e+05. What is the difference between the Aid flow (current US$) in Greece in 2011 and the Aid flow (current US$) in Finland in 2012?
Your response must be concise. -7.00e+05. What is the difference between the Aid flow (current US$) in Luxembourg in 2011 and the Aid flow (current US$) in Australia in 2012?
Offer a terse response. 3.69e+06. What is the difference between the Aid flow (current US$) in Luxembourg in 2011 and the Aid flow (current US$) in Finland in 2012?
Provide a short and direct response. 3.25e+06. What is the difference between the Aid flow (current US$) of Australia in 2011 and the Aid flow (current US$) of Finland in 2012?
Make the answer very short. -8.20e+05. What is the difference between the Aid flow (current US$) of Greece in 2011 and the Aid flow (current US$) of Luxembourg in 2013?
Make the answer very short. -1.90e+05. What is the difference between the Aid flow (current US$) of Greece in 2011 and the Aid flow (current US$) of Australia in 2013?
Provide a succinct answer. 5.70e+05. What is the difference between the Aid flow (current US$) in Greece in 2011 and the Aid flow (current US$) in Finland in 2013?
Offer a terse response. -5.30e+05. What is the difference between the Aid flow (current US$) in Luxembourg in 2011 and the Aid flow (current US$) in Australia in 2013?
Give a very brief answer. 4.52e+06. What is the difference between the Aid flow (current US$) in Luxembourg in 2011 and the Aid flow (current US$) in Finland in 2013?
Keep it short and to the point. 3.42e+06. What is the difference between the Aid flow (current US$) in Australia in 2011 and the Aid flow (current US$) in Finland in 2013?
Ensure brevity in your answer.  -6.50e+05. What is the difference between the Aid flow (current US$) of Greece in 2012 and the Aid flow (current US$) of Luxembourg in 2013?
Ensure brevity in your answer.  -1.90e+05. What is the difference between the Aid flow (current US$) in Greece in 2012 and the Aid flow (current US$) in Australia in 2013?
Your answer should be very brief. 5.70e+05. What is the difference between the Aid flow (current US$) in Greece in 2012 and the Aid flow (current US$) in Finland in 2013?
Make the answer very short. -5.30e+05. What is the difference between the Aid flow (current US$) of Luxembourg in 2012 and the Aid flow (current US$) of Australia in 2013?
Make the answer very short. 1.31e+06. What is the difference between the Aid flow (current US$) of Luxembourg in 2012 and the Aid flow (current US$) of Finland in 2013?
Your answer should be very brief. 2.10e+05. What is the difference between the Aid flow (current US$) of Australia in 2012 and the Aid flow (current US$) of Finland in 2013?
Offer a very short reply. -2.70e+05. What is the average Aid flow (current US$) of Greece per year?
Keep it short and to the point. 8.40e+06. What is the average Aid flow (current US$) of Luxembourg per year?
Give a very brief answer. 1.67e+06. What is the average Aid flow (current US$) of Australia per year?
Your answer should be compact. 3.77e+05. What is the average Aid flow (current US$) in Finland per year?
Give a very brief answer. 9.24e+05. In the year 2005, what is the difference between the Aid flow (current US$) of Greece and Aid flow (current US$) of Luxembourg?
Make the answer very short. 1.68e+07. In the year 2005, what is the difference between the Aid flow (current US$) of Greece and Aid flow (current US$) of Australia?
Make the answer very short. 1.72e+07. In the year 2005, what is the difference between the Aid flow (current US$) of Greece and Aid flow (current US$) of Finland?
Offer a terse response. 1.73e+07. In the year 2006, what is the difference between the Aid flow (current US$) in Greece and Aid flow (current US$) in Luxembourg?
Ensure brevity in your answer.  1.05e+07. In the year 2006, what is the difference between the Aid flow (current US$) in Greece and Aid flow (current US$) in Australia?
Keep it short and to the point. 1.08e+07. In the year 2006, what is the difference between the Aid flow (current US$) in Greece and Aid flow (current US$) in Finland?
Give a very brief answer. 1.09e+07. In the year 2006, what is the difference between the Aid flow (current US$) in Australia and Aid flow (current US$) in Finland?
Make the answer very short. 1.30e+05. In the year 2007, what is the difference between the Aid flow (current US$) in Greece and Aid flow (current US$) in Luxembourg?
Offer a terse response. 1.67e+07. In the year 2007, what is the difference between the Aid flow (current US$) in Greece and Aid flow (current US$) in Australia?
Give a very brief answer. 1.67e+07. In the year 2007, what is the difference between the Aid flow (current US$) in Greece and Aid flow (current US$) in Finland?
Make the answer very short. 1.67e+07. In the year 2007, what is the difference between the Aid flow (current US$) in Luxembourg and Aid flow (current US$) in Australia?
Offer a very short reply. -6.00e+04. In the year 2007, what is the difference between the Aid flow (current US$) in Luxembourg and Aid flow (current US$) in Finland?
Your response must be concise. -2.00e+04. In the year 2007, what is the difference between the Aid flow (current US$) of Australia and Aid flow (current US$) of Finland?
Your response must be concise. 4.00e+04. In the year 2008, what is the difference between the Aid flow (current US$) in Greece and Aid flow (current US$) in Luxembourg?
Ensure brevity in your answer.  9.99e+06. In the year 2008, what is the difference between the Aid flow (current US$) of Greece and Aid flow (current US$) of Australia?
Ensure brevity in your answer.  9.98e+06. In the year 2008, what is the difference between the Aid flow (current US$) of Greece and Aid flow (current US$) of Finland?
Make the answer very short. 9.02e+06. In the year 2008, what is the difference between the Aid flow (current US$) in Luxembourg and Aid flow (current US$) in Australia?
Keep it short and to the point. -10000. In the year 2008, what is the difference between the Aid flow (current US$) of Luxembourg and Aid flow (current US$) of Finland?
Provide a succinct answer. -9.70e+05. In the year 2008, what is the difference between the Aid flow (current US$) in Australia and Aid flow (current US$) in Finland?
Offer a very short reply. -9.60e+05. In the year 2009, what is the difference between the Aid flow (current US$) in Greece and Aid flow (current US$) in Luxembourg?
Your answer should be compact. 1.78e+07. In the year 2009, what is the difference between the Aid flow (current US$) of Greece and Aid flow (current US$) of Australia?
Offer a terse response. 1.77e+07. In the year 2009, what is the difference between the Aid flow (current US$) of Greece and Aid flow (current US$) of Finland?
Your answer should be compact. 1.78e+07. In the year 2009, what is the difference between the Aid flow (current US$) in Australia and Aid flow (current US$) in Finland?
Give a very brief answer. 1.00e+05. In the year 2010, what is the difference between the Aid flow (current US$) of Greece and Aid flow (current US$) of Luxembourg?
Provide a short and direct response. -5.94e+06. In the year 2010, what is the difference between the Aid flow (current US$) in Greece and Aid flow (current US$) in Australia?
Your answer should be very brief. -1.20e+05. In the year 2010, what is the difference between the Aid flow (current US$) of Greece and Aid flow (current US$) of Finland?
Give a very brief answer. -2.14e+06. In the year 2010, what is the difference between the Aid flow (current US$) in Luxembourg and Aid flow (current US$) in Australia?
Make the answer very short. 5.82e+06. In the year 2010, what is the difference between the Aid flow (current US$) in Luxembourg and Aid flow (current US$) in Finland?
Keep it short and to the point. 3.80e+06. In the year 2010, what is the difference between the Aid flow (current US$) of Australia and Aid flow (current US$) of Finland?
Provide a short and direct response. -2.02e+06. In the year 2011, what is the difference between the Aid flow (current US$) in Greece and Aid flow (current US$) in Luxembourg?
Offer a very short reply. -3.95e+06. In the year 2011, what is the difference between the Aid flow (current US$) of Greece and Aid flow (current US$) of Finland?
Your answer should be compact. -6.60e+05. In the year 2011, what is the difference between the Aid flow (current US$) of Luxembourg and Aid flow (current US$) of Australia?
Offer a very short reply. 4.07e+06. In the year 2011, what is the difference between the Aid flow (current US$) of Luxembourg and Aid flow (current US$) of Finland?
Your answer should be compact. 3.29e+06. In the year 2011, what is the difference between the Aid flow (current US$) in Australia and Aid flow (current US$) in Finland?
Your answer should be compact. -7.80e+05. In the year 2012, what is the difference between the Aid flow (current US$) in Greece and Aid flow (current US$) in Luxembourg?
Your answer should be very brief. -7.40e+05. In the year 2012, what is the difference between the Aid flow (current US$) of Greece and Aid flow (current US$) of Australia?
Give a very brief answer. -2.60e+05. In the year 2012, what is the difference between the Aid flow (current US$) of Greece and Aid flow (current US$) of Finland?
Offer a very short reply. -7.00e+05. In the year 2012, what is the difference between the Aid flow (current US$) of Luxembourg and Aid flow (current US$) of Australia?
Your response must be concise. 4.80e+05. In the year 2012, what is the difference between the Aid flow (current US$) in Australia and Aid flow (current US$) in Finland?
Make the answer very short. -4.40e+05. In the year 2013, what is the difference between the Aid flow (current US$) of Greece and Aid flow (current US$) of Luxembourg?
Provide a succinct answer. -5.40e+05. In the year 2013, what is the difference between the Aid flow (current US$) in Greece and Aid flow (current US$) in Australia?
Your response must be concise. 2.20e+05. In the year 2013, what is the difference between the Aid flow (current US$) of Greece and Aid flow (current US$) of Finland?
Provide a succinct answer. -8.80e+05. In the year 2013, what is the difference between the Aid flow (current US$) of Luxembourg and Aid flow (current US$) of Australia?
Your answer should be very brief. 7.60e+05. In the year 2013, what is the difference between the Aid flow (current US$) in Australia and Aid flow (current US$) in Finland?
Offer a terse response. -1.10e+06. What is the ratio of the Aid flow (current US$) in Greece in 2005 to that in 2006?
Offer a terse response. 1.58. What is the ratio of the Aid flow (current US$) of Luxembourg in 2005 to that in 2006?
Offer a very short reply. 1.04. What is the ratio of the Aid flow (current US$) in Luxembourg in 2005 to that in 2007?
Give a very brief answer. 0.9. What is the ratio of the Aid flow (current US$) of Australia in 2005 to that in 2007?
Offer a terse response. 0.21. What is the ratio of the Aid flow (current US$) in Finland in 2005 to that in 2007?
Your response must be concise. 0.04. What is the ratio of the Aid flow (current US$) in Greece in 2005 to that in 2008?
Offer a terse response. 1.71. What is the ratio of the Aid flow (current US$) in Luxembourg in 2005 to that in 2008?
Provide a succinct answer. 3.36. What is the ratio of the Aid flow (current US$) of Finland in 2005 to that in 2008?
Offer a very short reply. 0.02. What is the ratio of the Aid flow (current US$) in Greece in 2005 to that in 2009?
Offer a very short reply. 0.96. What is the ratio of the Aid flow (current US$) of Luxembourg in 2005 to that in 2009?
Provide a short and direct response. 2.61. What is the ratio of the Aid flow (current US$) of Australia in 2005 to that in 2009?
Offer a very short reply. 0.48. What is the ratio of the Aid flow (current US$) in Finland in 2005 to that in 2009?
Provide a succinct answer. 0.13. What is the ratio of the Aid flow (current US$) in Greece in 2005 to that in 2010?
Make the answer very short. 123.43. What is the ratio of the Aid flow (current US$) of Luxembourg in 2005 to that in 2010?
Your answer should be very brief. 0.08. What is the ratio of the Aid flow (current US$) of Australia in 2005 to that in 2010?
Your answer should be very brief. 0.46. What is the ratio of the Aid flow (current US$) in Finland in 2005 to that in 2010?
Keep it short and to the point. 0.01. What is the ratio of the Aid flow (current US$) of Greece in 2005 to that in 2011?
Keep it short and to the point. 22.44. What is the ratio of the Aid flow (current US$) of Luxembourg in 2005 to that in 2011?
Offer a very short reply. 0.1. What is the ratio of the Aid flow (current US$) of Australia in 2005 to that in 2011?
Your answer should be compact. 0.18. What is the ratio of the Aid flow (current US$) in Finland in 2005 to that in 2011?
Make the answer very short. 0.01. What is the ratio of the Aid flow (current US$) in Greece in 2005 to that in 2012?
Ensure brevity in your answer.  22.44. What is the ratio of the Aid flow (current US$) in Luxembourg in 2005 to that in 2012?
Make the answer very short. 0.31. What is the ratio of the Aid flow (current US$) in Australia in 2005 to that in 2012?
Make the answer very short. 0.12. What is the ratio of the Aid flow (current US$) in Finland in 2005 to that in 2012?
Provide a short and direct response. 0.01. What is the ratio of the Aid flow (current US$) of Greece in 2005 to that in 2013?
Make the answer very short. 41.14. What is the ratio of the Aid flow (current US$) in Luxembourg in 2005 to that in 2013?
Make the answer very short. 0.49. What is the ratio of the Aid flow (current US$) in Australia in 2005 to that in 2013?
Your answer should be very brief. 0.6. What is the ratio of the Aid flow (current US$) of Finland in 2005 to that in 2013?
Give a very brief answer. 0.02. What is the ratio of the Aid flow (current US$) of Greece in 2006 to that in 2007?
Offer a very short reply. 0.63. What is the ratio of the Aid flow (current US$) in Luxembourg in 2006 to that in 2007?
Your answer should be very brief. 0.87. What is the ratio of the Aid flow (current US$) of Australia in 2006 to that in 2007?
Keep it short and to the point. 0.26. What is the ratio of the Aid flow (current US$) of Finland in 2006 to that in 2007?
Your response must be concise. 0.04. What is the ratio of the Aid flow (current US$) of Greece in 2006 to that in 2008?
Offer a terse response. 1.08. What is the ratio of the Aid flow (current US$) in Luxembourg in 2006 to that in 2008?
Your answer should be very brief. 3.21. What is the ratio of the Aid flow (current US$) of Finland in 2006 to that in 2008?
Your answer should be compact. 0.02. What is the ratio of the Aid flow (current US$) of Greece in 2006 to that in 2009?
Provide a short and direct response. 0.61. What is the ratio of the Aid flow (current US$) of Finland in 2006 to that in 2009?
Your answer should be very brief. 0.13. What is the ratio of the Aid flow (current US$) of Greece in 2006 to that in 2010?
Your answer should be very brief. 77.93. What is the ratio of the Aid flow (current US$) in Luxembourg in 2006 to that in 2010?
Offer a terse response. 0.07. What is the ratio of the Aid flow (current US$) of Australia in 2006 to that in 2010?
Give a very brief answer. 0.58. What is the ratio of the Aid flow (current US$) of Finland in 2006 to that in 2010?
Give a very brief answer. 0.01. What is the ratio of the Aid flow (current US$) of Greece in 2006 to that in 2011?
Give a very brief answer. 14.17. What is the ratio of the Aid flow (current US$) of Luxembourg in 2006 to that in 2011?
Your response must be concise. 0.1. What is the ratio of the Aid flow (current US$) of Australia in 2006 to that in 2011?
Offer a terse response. 0.23. What is the ratio of the Aid flow (current US$) in Finland in 2006 to that in 2011?
Make the answer very short. 0.01. What is the ratio of the Aid flow (current US$) in Greece in 2006 to that in 2012?
Ensure brevity in your answer.  14.17. What is the ratio of the Aid flow (current US$) of Luxembourg in 2006 to that in 2012?
Make the answer very short. 0.3. What is the ratio of the Aid flow (current US$) of Australia in 2006 to that in 2012?
Offer a terse response. 0.15. What is the ratio of the Aid flow (current US$) in Finland in 2006 to that in 2012?
Your answer should be very brief. 0.01. What is the ratio of the Aid flow (current US$) of Greece in 2006 to that in 2013?
Provide a short and direct response. 25.98. What is the ratio of the Aid flow (current US$) in Luxembourg in 2006 to that in 2013?
Your answer should be very brief. 0.47. What is the ratio of the Aid flow (current US$) in Australia in 2006 to that in 2013?
Give a very brief answer. 0.75. What is the ratio of the Aid flow (current US$) in Finland in 2006 to that in 2013?
Keep it short and to the point. 0.02. What is the ratio of the Aid flow (current US$) in Greece in 2007 to that in 2008?
Give a very brief answer. 1.7. What is the ratio of the Aid flow (current US$) of Luxembourg in 2007 to that in 2008?
Your answer should be very brief. 3.71. What is the ratio of the Aid flow (current US$) of Australia in 2007 to that in 2008?
Your answer should be compact. 3.87. What is the ratio of the Aid flow (current US$) of Finland in 2007 to that in 2008?
Keep it short and to the point. 0.49. What is the ratio of the Aid flow (current US$) of Greece in 2007 to that in 2009?
Provide a succinct answer. 0.96. What is the ratio of the Aid flow (current US$) in Luxembourg in 2007 to that in 2009?
Make the answer very short. 2.89. What is the ratio of the Aid flow (current US$) of Australia in 2007 to that in 2009?
Provide a succinct answer. 2.32. What is the ratio of the Aid flow (current US$) in Greece in 2007 to that in 2010?
Keep it short and to the point. 123.21. What is the ratio of the Aid flow (current US$) of Luxembourg in 2007 to that in 2010?
Offer a very short reply. 0.09. What is the ratio of the Aid flow (current US$) of Australia in 2007 to that in 2010?
Make the answer very short. 2.23. What is the ratio of the Aid flow (current US$) of Finland in 2007 to that in 2010?
Make the answer very short. 0.24. What is the ratio of the Aid flow (current US$) in Greece in 2007 to that in 2011?
Give a very brief answer. 22.4. What is the ratio of the Aid flow (current US$) in Luxembourg in 2007 to that in 2011?
Give a very brief answer. 0.11. What is the ratio of the Aid flow (current US$) of Australia in 2007 to that in 2011?
Your answer should be very brief. 0.89. What is the ratio of the Aid flow (current US$) in Finland in 2007 to that in 2011?
Ensure brevity in your answer.  0.38. What is the ratio of the Aid flow (current US$) of Greece in 2007 to that in 2012?
Offer a terse response. 22.4. What is the ratio of the Aid flow (current US$) in Luxembourg in 2007 to that in 2012?
Your answer should be compact. 0.34. What is the ratio of the Aid flow (current US$) of Australia in 2007 to that in 2012?
Provide a succinct answer. 0.56. What is the ratio of the Aid flow (current US$) in Finland in 2007 to that in 2012?
Give a very brief answer. 0.37. What is the ratio of the Aid flow (current US$) in Greece in 2007 to that in 2013?
Your response must be concise. 41.07. What is the ratio of the Aid flow (current US$) of Luxembourg in 2007 to that in 2013?
Give a very brief answer. 0.54. What is the ratio of the Aid flow (current US$) in Australia in 2007 to that in 2013?
Provide a short and direct response. 2.9. What is the ratio of the Aid flow (current US$) in Finland in 2007 to that in 2013?
Provide a succinct answer. 0.42. What is the ratio of the Aid flow (current US$) of Greece in 2008 to that in 2009?
Offer a terse response. 0.56. What is the ratio of the Aid flow (current US$) in Luxembourg in 2008 to that in 2009?
Ensure brevity in your answer.  0.78. What is the ratio of the Aid flow (current US$) of Finland in 2008 to that in 2009?
Keep it short and to the point. 7.4. What is the ratio of the Aid flow (current US$) in Greece in 2008 to that in 2010?
Provide a succinct answer. 72.36. What is the ratio of the Aid flow (current US$) in Luxembourg in 2008 to that in 2010?
Offer a terse response. 0.02. What is the ratio of the Aid flow (current US$) of Australia in 2008 to that in 2010?
Your response must be concise. 0.58. What is the ratio of the Aid flow (current US$) in Finland in 2008 to that in 2010?
Your answer should be compact. 0.49. What is the ratio of the Aid flow (current US$) of Greece in 2008 to that in 2011?
Make the answer very short. 13.16. What is the ratio of the Aid flow (current US$) in Luxembourg in 2008 to that in 2011?
Give a very brief answer. 0.03. What is the ratio of the Aid flow (current US$) in Australia in 2008 to that in 2011?
Provide a succinct answer. 0.23. What is the ratio of the Aid flow (current US$) in Finland in 2008 to that in 2011?
Keep it short and to the point. 0.78. What is the ratio of the Aid flow (current US$) of Greece in 2008 to that in 2012?
Provide a succinct answer. 13.16. What is the ratio of the Aid flow (current US$) of Luxembourg in 2008 to that in 2012?
Offer a terse response. 0.09. What is the ratio of the Aid flow (current US$) in Australia in 2008 to that in 2012?
Keep it short and to the point. 0.15. What is the ratio of the Aid flow (current US$) of Finland in 2008 to that in 2012?
Provide a succinct answer. 0.76. What is the ratio of the Aid flow (current US$) in Greece in 2008 to that in 2013?
Give a very brief answer. 24.12. What is the ratio of the Aid flow (current US$) in Luxembourg in 2008 to that in 2013?
Offer a very short reply. 0.15. What is the ratio of the Aid flow (current US$) of Finland in 2008 to that in 2013?
Your answer should be very brief. 0.85. What is the ratio of the Aid flow (current US$) of Greece in 2009 to that in 2010?
Keep it short and to the point. 128.36. What is the ratio of the Aid flow (current US$) of Luxembourg in 2009 to that in 2010?
Give a very brief answer. 0.03. What is the ratio of the Aid flow (current US$) of Australia in 2009 to that in 2010?
Offer a terse response. 0.96. What is the ratio of the Aid flow (current US$) in Finland in 2009 to that in 2010?
Your answer should be compact. 0.07. What is the ratio of the Aid flow (current US$) of Greece in 2009 to that in 2011?
Provide a succinct answer. 23.34. What is the ratio of the Aid flow (current US$) in Luxembourg in 2009 to that in 2011?
Offer a very short reply. 0.04. What is the ratio of the Aid flow (current US$) of Australia in 2009 to that in 2011?
Offer a terse response. 0.38. What is the ratio of the Aid flow (current US$) of Finland in 2009 to that in 2011?
Make the answer very short. 0.1. What is the ratio of the Aid flow (current US$) of Greece in 2009 to that in 2012?
Give a very brief answer. 23.34. What is the ratio of the Aid flow (current US$) of Luxembourg in 2009 to that in 2012?
Give a very brief answer. 0.12. What is the ratio of the Aid flow (current US$) in Australia in 2009 to that in 2012?
Keep it short and to the point. 0.24. What is the ratio of the Aid flow (current US$) of Finland in 2009 to that in 2012?
Your response must be concise. 0.1. What is the ratio of the Aid flow (current US$) of Greece in 2009 to that in 2013?
Provide a succinct answer. 42.79. What is the ratio of the Aid flow (current US$) in Luxembourg in 2009 to that in 2013?
Provide a succinct answer. 0.19. What is the ratio of the Aid flow (current US$) of Australia in 2009 to that in 2013?
Provide a short and direct response. 1.25. What is the ratio of the Aid flow (current US$) of Finland in 2009 to that in 2013?
Make the answer very short. 0.12. What is the ratio of the Aid flow (current US$) of Greece in 2010 to that in 2011?
Provide a short and direct response. 0.18. What is the ratio of the Aid flow (current US$) of Luxembourg in 2010 to that in 2011?
Your answer should be very brief. 1.29. What is the ratio of the Aid flow (current US$) in Finland in 2010 to that in 2011?
Ensure brevity in your answer.  1.59. What is the ratio of the Aid flow (current US$) in Greece in 2010 to that in 2012?
Provide a succinct answer. 0.18. What is the ratio of the Aid flow (current US$) in Luxembourg in 2010 to that in 2012?
Your answer should be compact. 4.03. What is the ratio of the Aid flow (current US$) of Australia in 2010 to that in 2012?
Your answer should be very brief. 0.25. What is the ratio of the Aid flow (current US$) in Finland in 2010 to that in 2012?
Ensure brevity in your answer.  1.55. What is the ratio of the Aid flow (current US$) of Luxembourg in 2010 to that in 2013?
Provide a succinct answer. 6.33. What is the ratio of the Aid flow (current US$) of Australia in 2010 to that in 2013?
Provide a short and direct response. 1.3. What is the ratio of the Aid flow (current US$) of Finland in 2010 to that in 2013?
Keep it short and to the point. 1.75. What is the ratio of the Aid flow (current US$) in Greece in 2011 to that in 2012?
Provide a short and direct response. 1. What is the ratio of the Aid flow (current US$) of Luxembourg in 2011 to that in 2012?
Your response must be concise. 3.13. What is the ratio of the Aid flow (current US$) of Australia in 2011 to that in 2012?
Offer a terse response. 0.63. What is the ratio of the Aid flow (current US$) in Finland in 2011 to that in 2012?
Offer a terse response. 0.97. What is the ratio of the Aid flow (current US$) in Greece in 2011 to that in 2013?
Your response must be concise. 1.83. What is the ratio of the Aid flow (current US$) in Luxembourg in 2011 to that in 2013?
Your response must be concise. 4.92. What is the ratio of the Aid flow (current US$) of Finland in 2011 to that in 2013?
Your answer should be compact. 1.1. What is the ratio of the Aid flow (current US$) in Greece in 2012 to that in 2013?
Keep it short and to the point. 1.83. What is the ratio of the Aid flow (current US$) in Luxembourg in 2012 to that in 2013?
Offer a very short reply. 1.57. What is the ratio of the Aid flow (current US$) in Australia in 2012 to that in 2013?
Make the answer very short. 5.15. What is the ratio of the Aid flow (current US$) in Finland in 2012 to that in 2013?
Make the answer very short. 1.13. What is the difference between the highest and the second highest Aid flow (current US$) in Greece?
Ensure brevity in your answer.  6.90e+05. What is the difference between the highest and the second highest Aid flow (current US$) of Luxembourg?
Your answer should be very brief. 1.36e+06. What is the difference between the highest and the second highest Aid flow (current US$) in Finland?
Provide a short and direct response. 8.10e+05. What is the difference between the highest and the lowest Aid flow (current US$) of Greece?
Make the answer very short. 1.78e+07. What is the difference between the highest and the lowest Aid flow (current US$) in Luxembourg?
Your answer should be very brief. 5.94e+06. What is the difference between the highest and the lowest Aid flow (current US$) in Australia?
Your response must be concise. 9.10e+05. What is the difference between the highest and the lowest Aid flow (current US$) in Finland?
Provide a succinct answer. 2.26e+06. 